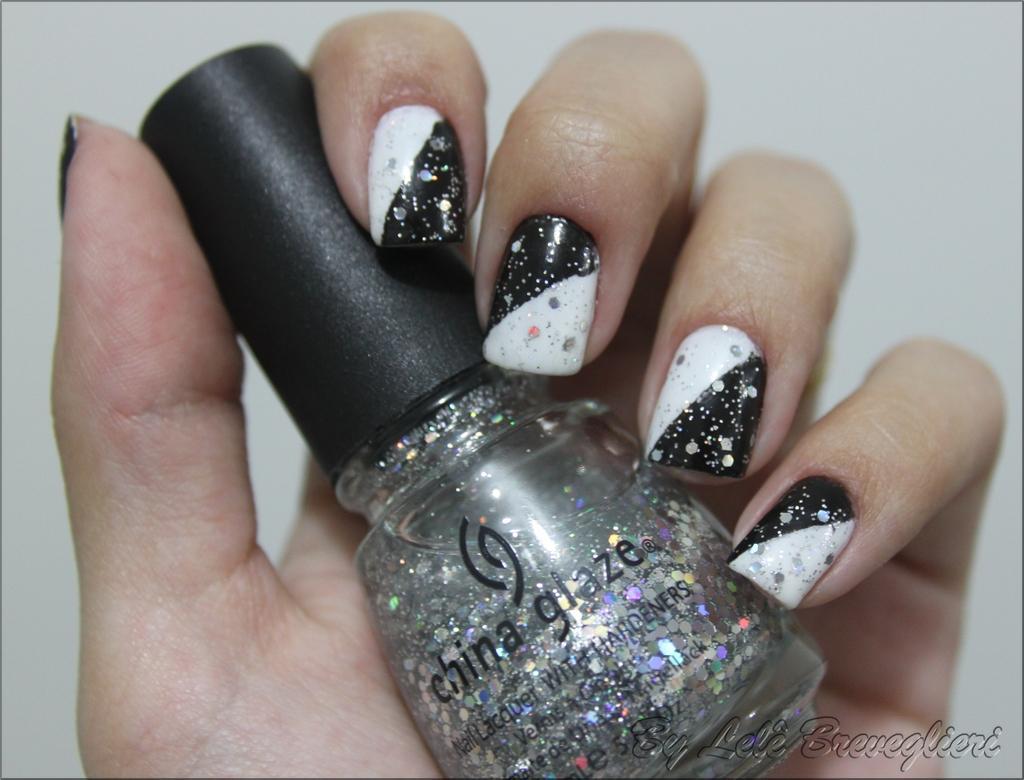How would you summarize this image in a sentence or two? A human is holding the nail polish bottle. It is in black color. 